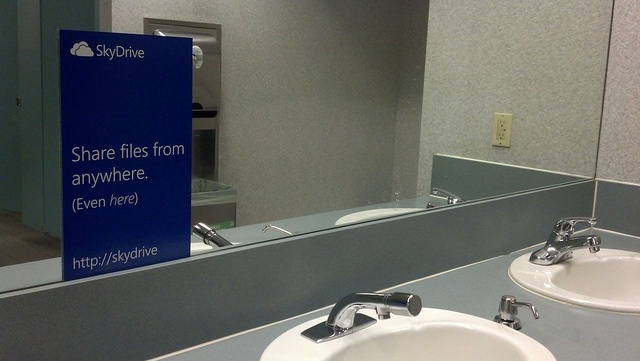Describe the objects in this image and their specific colors. I can see sink in black, ivory, lightgray, and darkgray tones and sink in black, lightgray, tan, and darkgray tones in this image. 